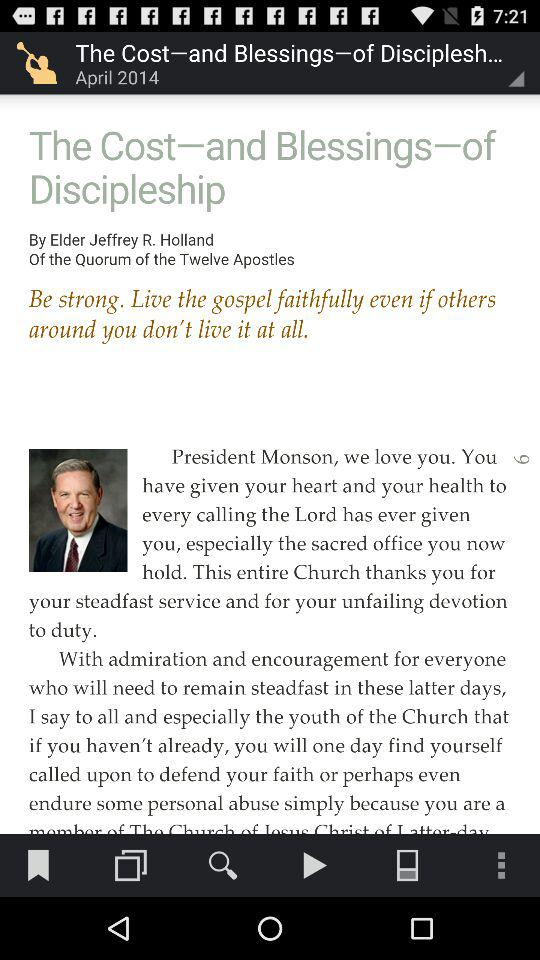Who is the author of this article? The author is Elder Jeffrey R. Holland. 